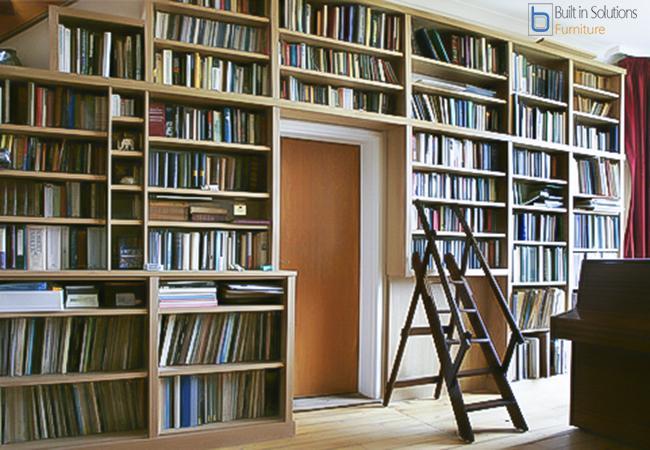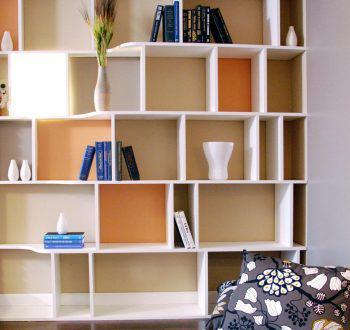The first image is the image on the left, the second image is the image on the right. Evaluate the accuracy of this statement regarding the images: "In one image, a shelf unit that is two shelves wide and at least three shelves tall is open at the back to a wall with a decorative overall design.". Is it true? Answer yes or no. No. The first image is the image on the left, the second image is the image on the right. Given the left and right images, does the statement "One of the bookcases as a patterned back wall." hold true? Answer yes or no. No. 